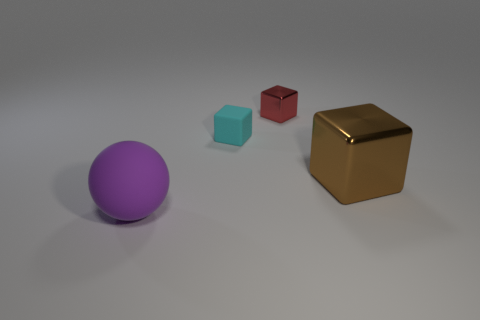Add 1 large brown blocks. How many objects exist? 5 Subtract all spheres. How many objects are left? 3 Add 1 tiny red metal blocks. How many tiny red metal blocks are left? 2 Add 1 rubber cubes. How many rubber cubes exist? 2 Subtract 0 yellow spheres. How many objects are left? 4 Subtract all big balls. Subtract all red blocks. How many objects are left? 2 